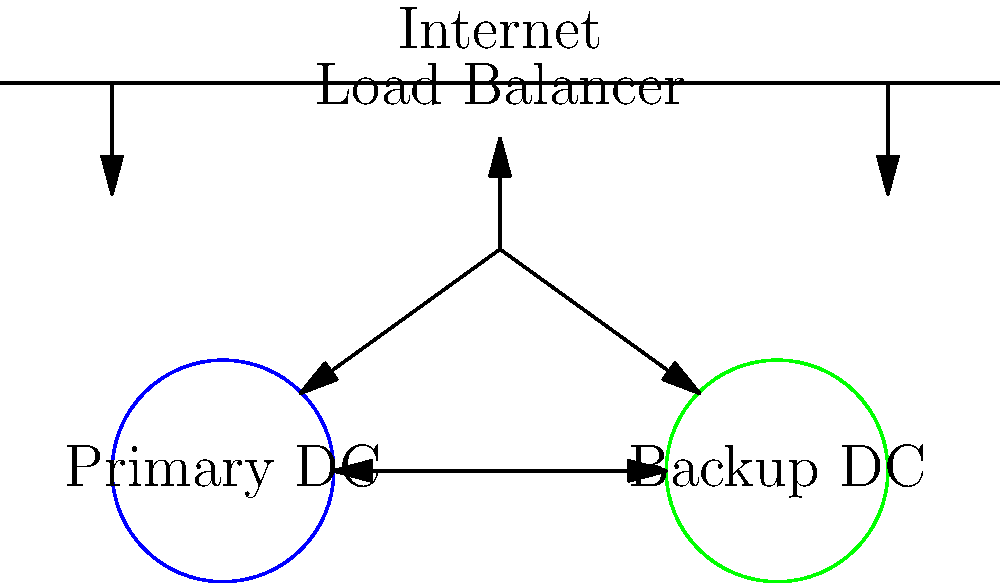In the network diagram shown, which component is crucial for distributing incoming claims processing requests and ensuring continuous operations in case of a data center failure? To answer this question, let's analyze the components of the network diagram:

1. We see two circles labeled "Primary DC" and "Backup DC", representing the primary and backup data centers.
2. There are connections between these data centers, indicating data replication or synchronization.
3. Above the data centers, we see a component labeled "Load Balancer".
4. The Load Balancer has connections to both data centers and is positioned between the internet and the data centers.

The Load Balancer plays a crucial role in this network setup:

1. It distributes incoming requests: The Load Balancer receives incoming claims processing requests from the internet and distributes them between the primary and backup data centers.
2. It ensures continuous operations: If one data center fails, the Load Balancer can redirect all traffic to the functioning data center, maintaining continuous operations.
3. It provides failover capability: In case of a failure in the primary data center, the Load Balancer can automatically switch traffic to the backup data center without interruption to the service.
4. It optimizes resource utilization: By distributing requests, it prevents overloading of a single data center, improving overall system efficiency.

Therefore, the Load Balancer is the component crucial for distributing incoming claims processing requests and ensuring continuous operations in case of a data center failure.
Answer: Load Balancer 